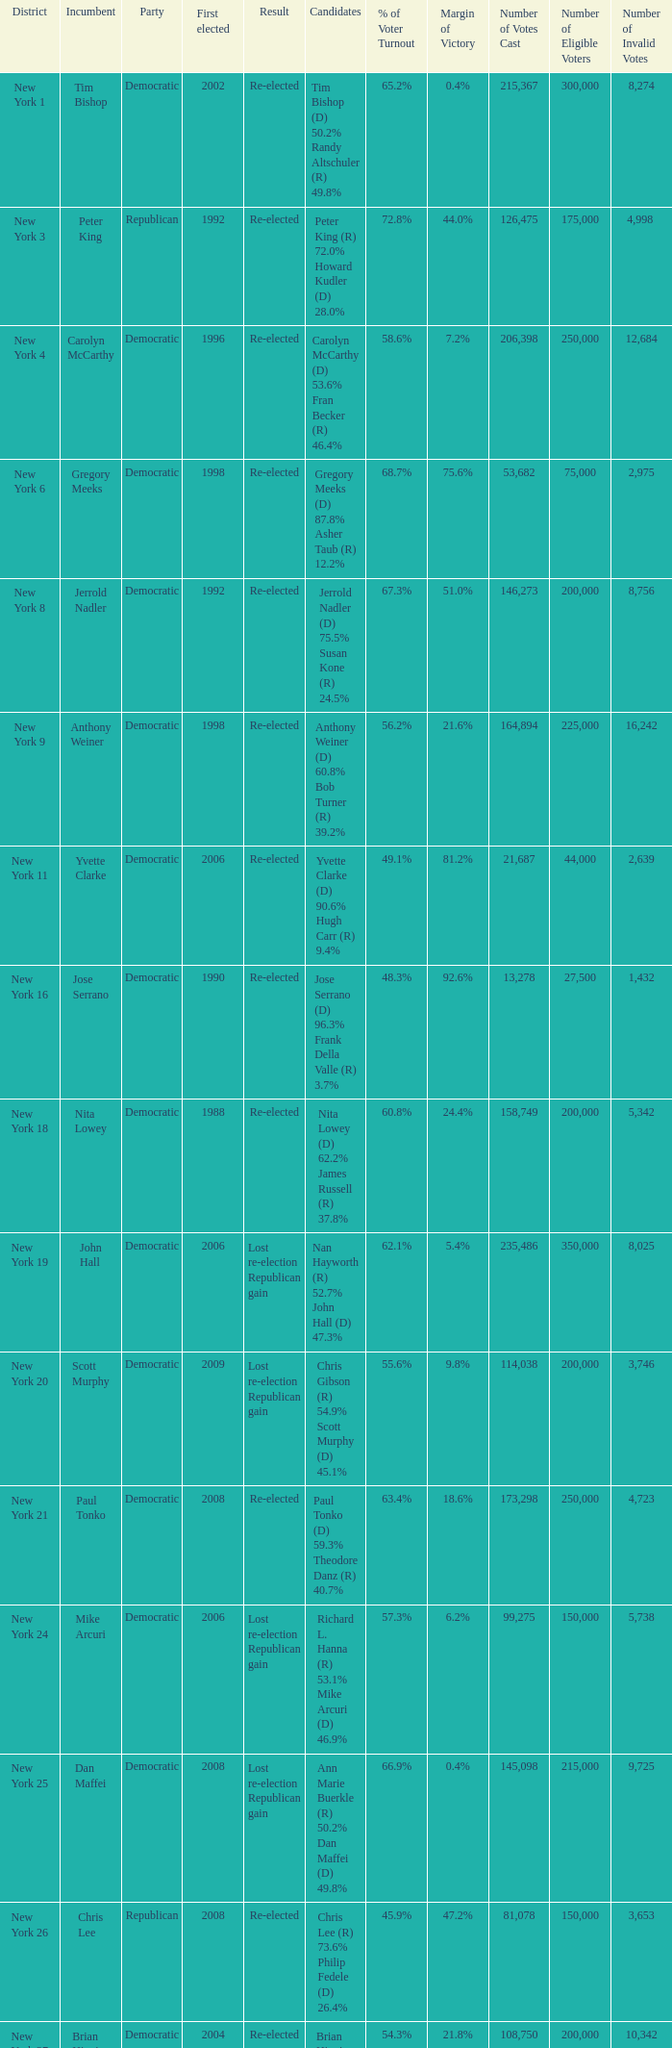Name the first elected for re-elected and brian higgins 2004.0. 